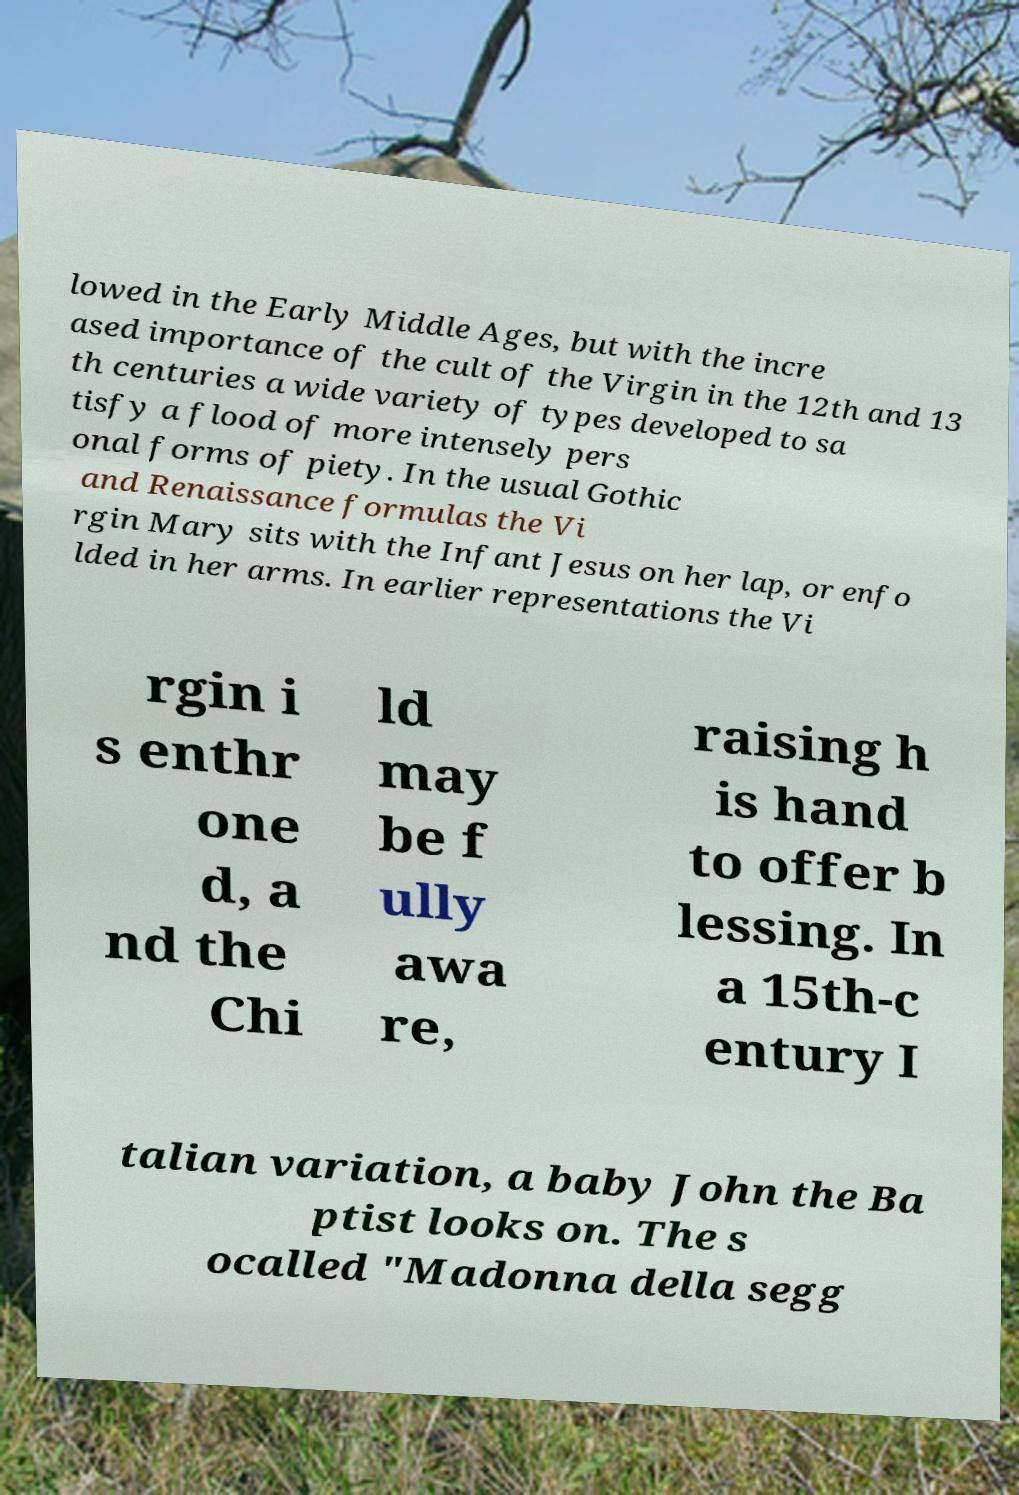Please identify and transcribe the text found in this image. lowed in the Early Middle Ages, but with the incre ased importance of the cult of the Virgin in the 12th and 13 th centuries a wide variety of types developed to sa tisfy a flood of more intensely pers onal forms of piety. In the usual Gothic and Renaissance formulas the Vi rgin Mary sits with the Infant Jesus on her lap, or enfo lded in her arms. In earlier representations the Vi rgin i s enthr one d, a nd the Chi ld may be f ully awa re, raising h is hand to offer b lessing. In a 15th-c entury I talian variation, a baby John the Ba ptist looks on. The s ocalled "Madonna della segg 